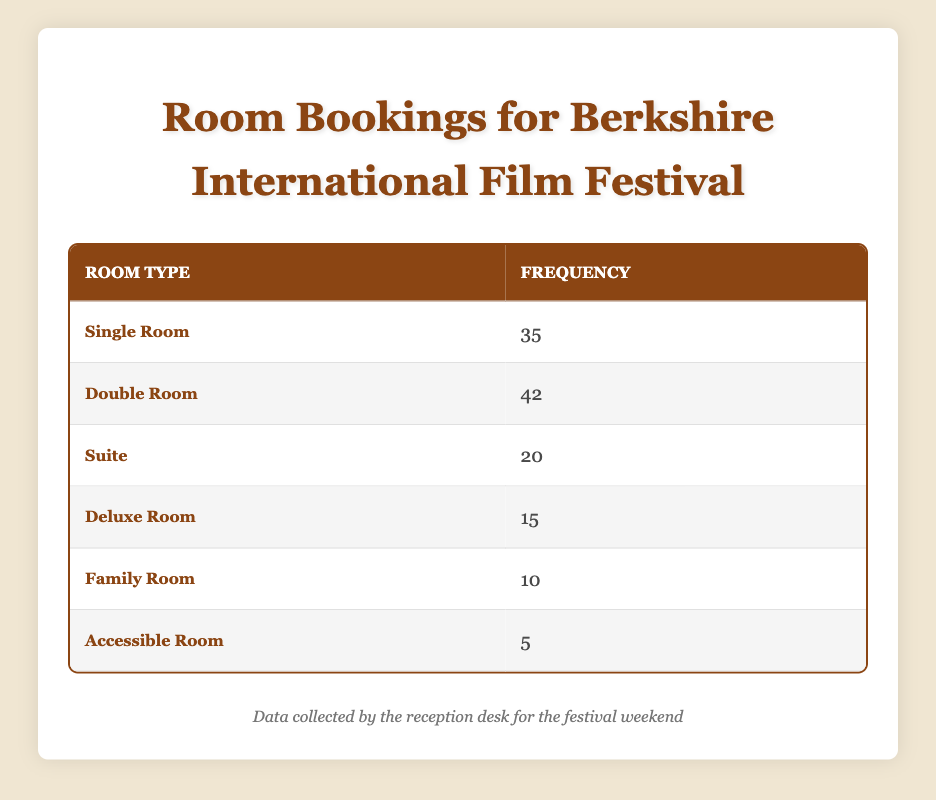What is the total number of rooms booked over the festival weekend? To find the total number of rooms booked, sum the booked counts for all room types: 35 (Single Room) + 42 (Double Room) + 20 (Suite) + 15 (Deluxe Room) + 10 (Family Room) + 5 (Accessible Room) = 127
Answer: 127 Which room type had the highest number of bookings? By comparing the booked counts for each room type, the Double Room has the highest count at 42, while other room types have lower counts.
Answer: Double Room How many more Double Rooms were booked than Accessible Rooms? Subtract the booked count of Accessible Rooms (5) from the booked count of Double Rooms (42): 42 - 5 = 37.
Answer: 37 Is it true that more than half of the total rooms booked were Single Rooms? First, find half of the total rooms: 127 / 2 = 63.5. Then, compare: 35 (Single Rooms) is less than 63.5, so the statement is false.
Answer: No What is the average number of bookings for the room types? To find the average, first sum the booked counts: 127 (total), then divide by the number of room types (6): 127 / 6 ≈ 21.17.
Answer: Approximately 21.17 If 10 more Family Rooms had been booked, how many would be booked in total? Adding 10 to the current count of Family Rooms (10) gives us 20. To find the new total, add 10 to the previous total of rooms booked: 127 + 10 = 137.
Answer: 137 Which room type had the least number of bookings? By examining the booked counts, the Accessible Room has the lowest count at 5 compared to other room types.
Answer: Accessible Room What is the difference in booked counts between Suites and Deluxe Rooms? Subtract the booked count for Deluxe Rooms (15) from Suites (20): 20 - 15 = 5.
Answer: 5 How many room types had bookings equal to or greater than 20? Count the room types with booked counts 20 or more: Single Room (35), Double Room (42), Suite (20). There are three room types that meet this criterion.
Answer: 3 